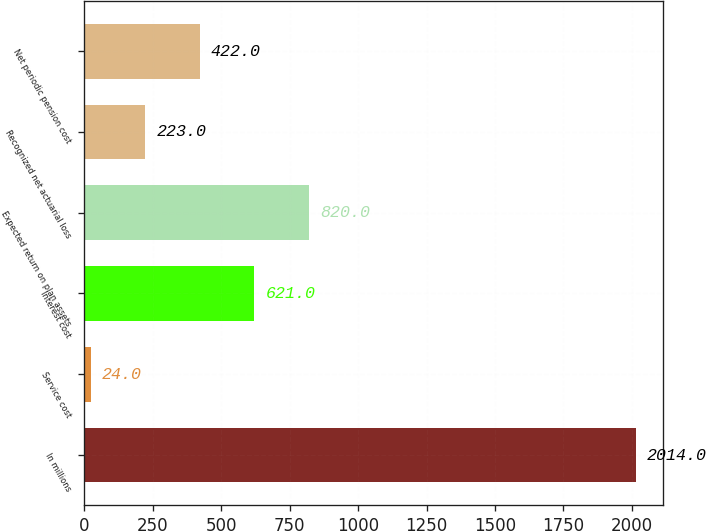Convert chart to OTSL. <chart><loc_0><loc_0><loc_500><loc_500><bar_chart><fcel>In millions<fcel>Service cost<fcel>Interest cost<fcel>Expected return on plan assets<fcel>Recognized net actuarial loss<fcel>Net periodic pension cost<nl><fcel>2014<fcel>24<fcel>621<fcel>820<fcel>223<fcel>422<nl></chart> 